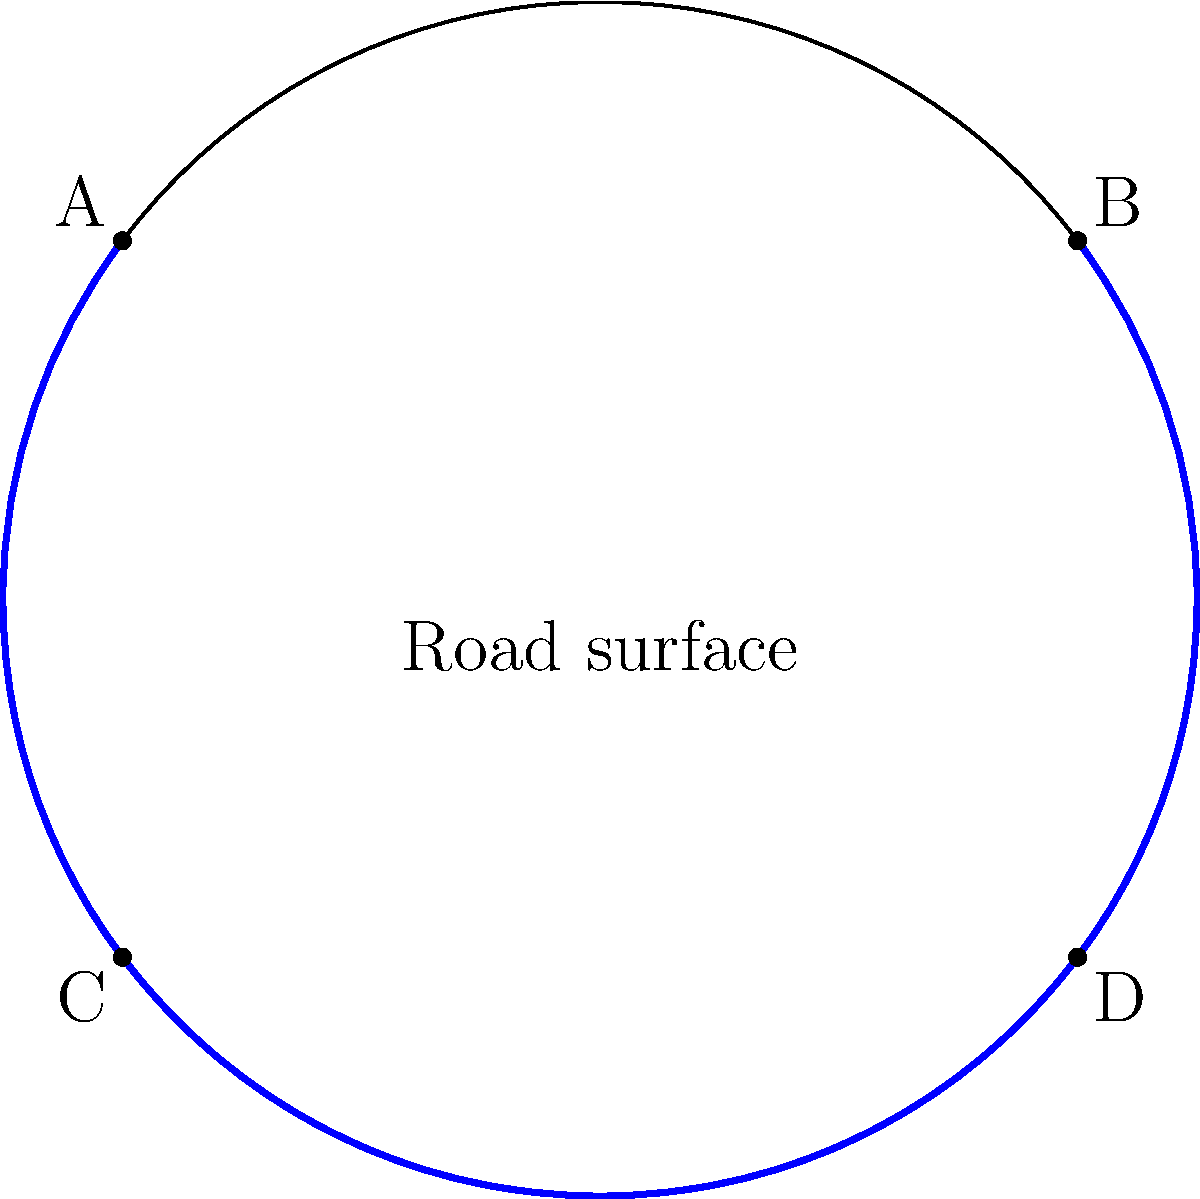In the context of designing curved road markings for a traffic calming measure, consider the illustration of parallel lines in elliptic geometry shown above. If the blue arcs represent road markings on a spherical surface, what is the relationship between these lines, and how does this differ from Euclidean parallel lines? To understand the relationship between these lines in elliptic geometry and how they differ from Euclidean parallel lines, let's follow these steps:

1. Elliptic geometry basics:
   - Elliptic geometry is a non-Euclidean geometry where there are no parallel lines.
   - It can be modeled on the surface of a sphere.

2. Analyzing the diagram:
   - The circle represents a cross-section of a sphere (the road surface).
   - The blue arcs (AB and CD) represent road markings on this spherical surface.

3. Properties of these lines in elliptic geometry:
   - These lines are called "great circles" on the sphere.
   - They are the equivalent of "straight lines" in elliptic geometry.
   - All great circles intersect at two antipodal points on the sphere.

4. Comparison with Euclidean parallel lines:
   - In Euclidean geometry, parallel lines never intersect.
   - In elliptic geometry, all lines (great circles) intersect.

5. Implications for road markings:
   - On a flat road (Euclidean), parallel lines remain equidistant.
   - On a curved road surface (elliptic), these "parallel" lines will converge.

6. Traffic calming application:
   - This convergence effect can create a visual illusion of the road narrowing.
   - Drivers may perceive the need to slow down, even if the physical road width remains constant.

Therefore, in elliptic geometry, these "parallel" road markings are actually great circles that will intersect, unlike Euclidean parallel lines which never meet.
Answer: Intersecting great circles, not parallel 